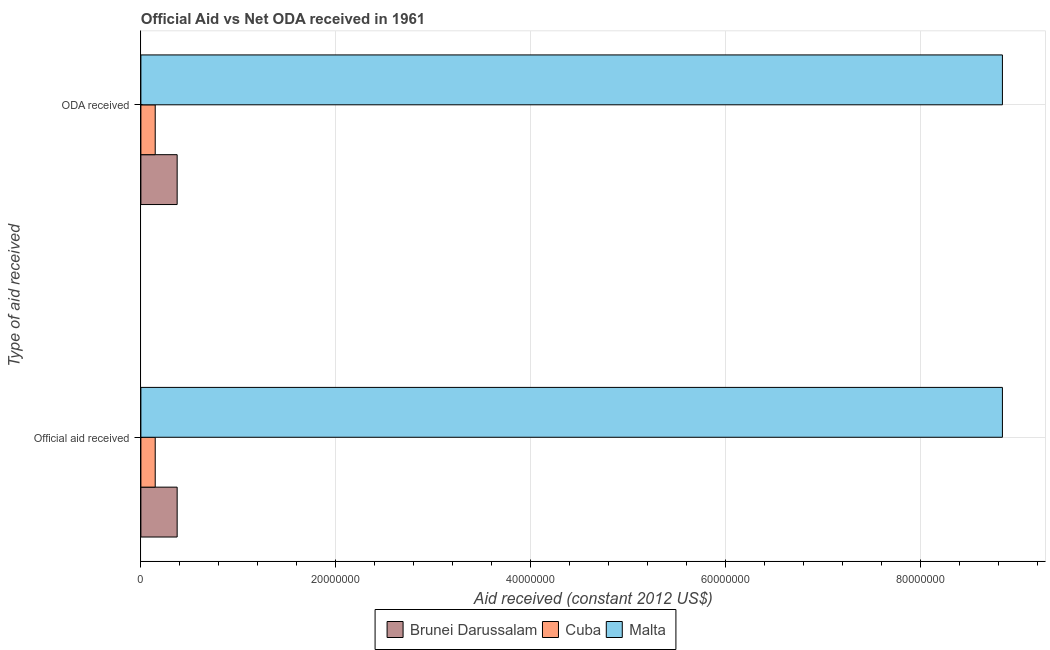How many different coloured bars are there?
Provide a short and direct response. 3. How many groups of bars are there?
Give a very brief answer. 2. Are the number of bars per tick equal to the number of legend labels?
Ensure brevity in your answer.  Yes. Are the number of bars on each tick of the Y-axis equal?
Your answer should be very brief. Yes. How many bars are there on the 1st tick from the top?
Give a very brief answer. 3. How many bars are there on the 1st tick from the bottom?
Offer a terse response. 3. What is the label of the 2nd group of bars from the top?
Offer a terse response. Official aid received. What is the oda received in Brunei Darussalam?
Ensure brevity in your answer.  3.72e+06. Across all countries, what is the maximum official aid received?
Offer a very short reply. 8.84e+07. Across all countries, what is the minimum official aid received?
Offer a very short reply. 1.47e+06. In which country was the oda received maximum?
Make the answer very short. Malta. In which country was the official aid received minimum?
Your answer should be compact. Cuba. What is the total official aid received in the graph?
Ensure brevity in your answer.  9.36e+07. What is the difference between the oda received in Malta and that in Cuba?
Provide a succinct answer. 8.69e+07. What is the difference between the oda received in Brunei Darussalam and the official aid received in Malta?
Keep it short and to the point. -8.46e+07. What is the average oda received per country?
Your answer should be very brief. 3.12e+07. What is the difference between the oda received and official aid received in Brunei Darussalam?
Provide a short and direct response. 0. In how many countries, is the official aid received greater than 76000000 US$?
Make the answer very short. 1. What is the ratio of the official aid received in Cuba to that in Brunei Darussalam?
Your answer should be very brief. 0.4. In how many countries, is the oda received greater than the average oda received taken over all countries?
Your response must be concise. 1. What does the 2nd bar from the top in Official aid received represents?
Provide a succinct answer. Cuba. What does the 3rd bar from the bottom in Official aid received represents?
Make the answer very short. Malta. How many bars are there?
Give a very brief answer. 6. Does the graph contain any zero values?
Offer a very short reply. No. Does the graph contain grids?
Give a very brief answer. Yes. Where does the legend appear in the graph?
Your answer should be compact. Bottom center. How many legend labels are there?
Give a very brief answer. 3. What is the title of the graph?
Offer a very short reply. Official Aid vs Net ODA received in 1961 . What is the label or title of the X-axis?
Offer a very short reply. Aid received (constant 2012 US$). What is the label or title of the Y-axis?
Your response must be concise. Type of aid received. What is the Aid received (constant 2012 US$) of Brunei Darussalam in Official aid received?
Keep it short and to the point. 3.72e+06. What is the Aid received (constant 2012 US$) in Cuba in Official aid received?
Offer a very short reply. 1.47e+06. What is the Aid received (constant 2012 US$) of Malta in Official aid received?
Your answer should be compact. 8.84e+07. What is the Aid received (constant 2012 US$) in Brunei Darussalam in ODA received?
Give a very brief answer. 3.72e+06. What is the Aid received (constant 2012 US$) in Cuba in ODA received?
Provide a succinct answer. 1.47e+06. What is the Aid received (constant 2012 US$) in Malta in ODA received?
Ensure brevity in your answer.  8.84e+07. Across all Type of aid received, what is the maximum Aid received (constant 2012 US$) of Brunei Darussalam?
Your answer should be compact. 3.72e+06. Across all Type of aid received, what is the maximum Aid received (constant 2012 US$) of Cuba?
Provide a short and direct response. 1.47e+06. Across all Type of aid received, what is the maximum Aid received (constant 2012 US$) of Malta?
Make the answer very short. 8.84e+07. Across all Type of aid received, what is the minimum Aid received (constant 2012 US$) in Brunei Darussalam?
Your response must be concise. 3.72e+06. Across all Type of aid received, what is the minimum Aid received (constant 2012 US$) in Cuba?
Offer a very short reply. 1.47e+06. Across all Type of aid received, what is the minimum Aid received (constant 2012 US$) of Malta?
Give a very brief answer. 8.84e+07. What is the total Aid received (constant 2012 US$) in Brunei Darussalam in the graph?
Your answer should be very brief. 7.44e+06. What is the total Aid received (constant 2012 US$) in Cuba in the graph?
Provide a short and direct response. 2.94e+06. What is the total Aid received (constant 2012 US$) in Malta in the graph?
Keep it short and to the point. 1.77e+08. What is the difference between the Aid received (constant 2012 US$) of Cuba in Official aid received and that in ODA received?
Provide a succinct answer. 0. What is the difference between the Aid received (constant 2012 US$) in Brunei Darussalam in Official aid received and the Aid received (constant 2012 US$) in Cuba in ODA received?
Keep it short and to the point. 2.25e+06. What is the difference between the Aid received (constant 2012 US$) in Brunei Darussalam in Official aid received and the Aid received (constant 2012 US$) in Malta in ODA received?
Give a very brief answer. -8.46e+07. What is the difference between the Aid received (constant 2012 US$) in Cuba in Official aid received and the Aid received (constant 2012 US$) in Malta in ODA received?
Your response must be concise. -8.69e+07. What is the average Aid received (constant 2012 US$) in Brunei Darussalam per Type of aid received?
Your response must be concise. 3.72e+06. What is the average Aid received (constant 2012 US$) in Cuba per Type of aid received?
Your answer should be compact. 1.47e+06. What is the average Aid received (constant 2012 US$) in Malta per Type of aid received?
Make the answer very short. 8.84e+07. What is the difference between the Aid received (constant 2012 US$) in Brunei Darussalam and Aid received (constant 2012 US$) in Cuba in Official aid received?
Give a very brief answer. 2.25e+06. What is the difference between the Aid received (constant 2012 US$) of Brunei Darussalam and Aid received (constant 2012 US$) of Malta in Official aid received?
Your answer should be compact. -8.46e+07. What is the difference between the Aid received (constant 2012 US$) of Cuba and Aid received (constant 2012 US$) of Malta in Official aid received?
Your answer should be very brief. -8.69e+07. What is the difference between the Aid received (constant 2012 US$) of Brunei Darussalam and Aid received (constant 2012 US$) of Cuba in ODA received?
Give a very brief answer. 2.25e+06. What is the difference between the Aid received (constant 2012 US$) in Brunei Darussalam and Aid received (constant 2012 US$) in Malta in ODA received?
Keep it short and to the point. -8.46e+07. What is the difference between the Aid received (constant 2012 US$) in Cuba and Aid received (constant 2012 US$) in Malta in ODA received?
Your answer should be compact. -8.69e+07. What is the ratio of the Aid received (constant 2012 US$) of Cuba in Official aid received to that in ODA received?
Make the answer very short. 1. What is the difference between the highest and the second highest Aid received (constant 2012 US$) in Brunei Darussalam?
Offer a terse response. 0. What is the difference between the highest and the second highest Aid received (constant 2012 US$) in Cuba?
Your answer should be compact. 0. What is the difference between the highest and the lowest Aid received (constant 2012 US$) in Brunei Darussalam?
Keep it short and to the point. 0. What is the difference between the highest and the lowest Aid received (constant 2012 US$) in Malta?
Your response must be concise. 0. 